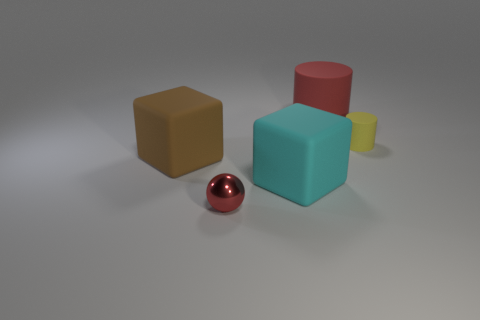Subtract all red cylinders. How many cylinders are left? 1 Subtract 1 cubes. How many cubes are left? 1 Subtract all blocks. How many objects are left? 3 Add 5 cylinders. How many objects exist? 10 Subtract all gray balls. Subtract all green cylinders. How many balls are left? 1 Subtract all yellow things. Subtract all tiny cylinders. How many objects are left? 3 Add 5 spheres. How many spheres are left? 6 Add 1 brown cylinders. How many brown cylinders exist? 1 Subtract 0 brown spheres. How many objects are left? 5 